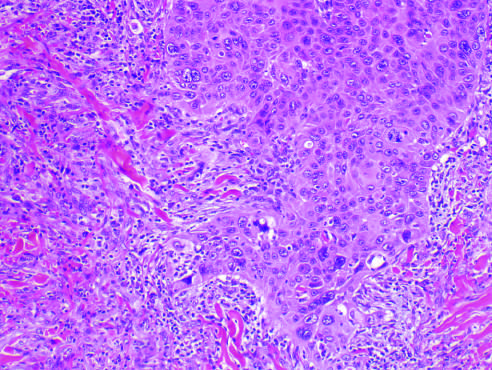what exhibit acantholysis?
Answer the question using a single word or phrase. Atypical squamous cells 